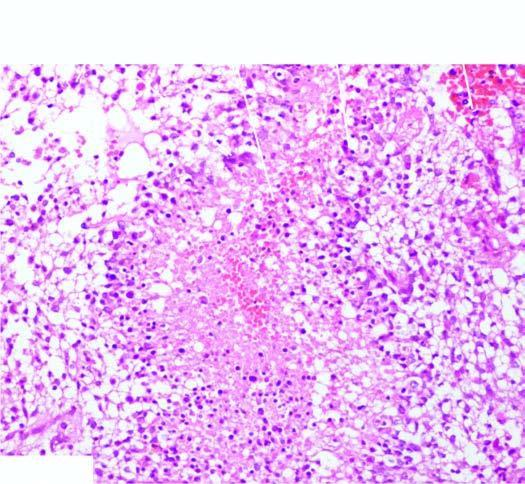s the kidney densely cellular having marked pleomorphism?
Answer the question using a single word or phrase. No 